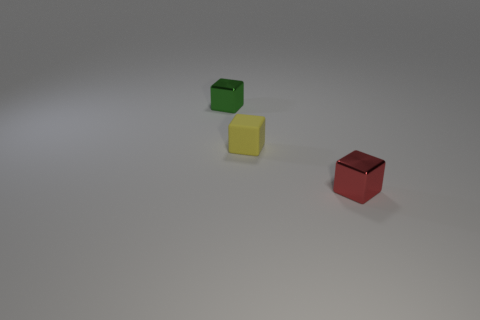Subtract all metallic cubes. How many cubes are left? 1 Add 2 large green balls. How many objects exist? 5 Subtract 0 red balls. How many objects are left? 3 Subtract all tiny red metal objects. Subtract all yellow matte cubes. How many objects are left? 1 Add 3 tiny green shiny objects. How many tiny green shiny objects are left? 4 Add 2 large rubber objects. How many large rubber objects exist? 2 